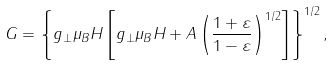<formula> <loc_0><loc_0><loc_500><loc_500>G = \left \{ g _ { \perp } \mu _ { B } H \left [ g _ { \perp } \mu _ { B } H + A \left ( \frac { 1 + \varepsilon } { 1 - \varepsilon } \right ) ^ { 1 / 2 } \right ] \right \} ^ { 1 / 2 } ,</formula> 